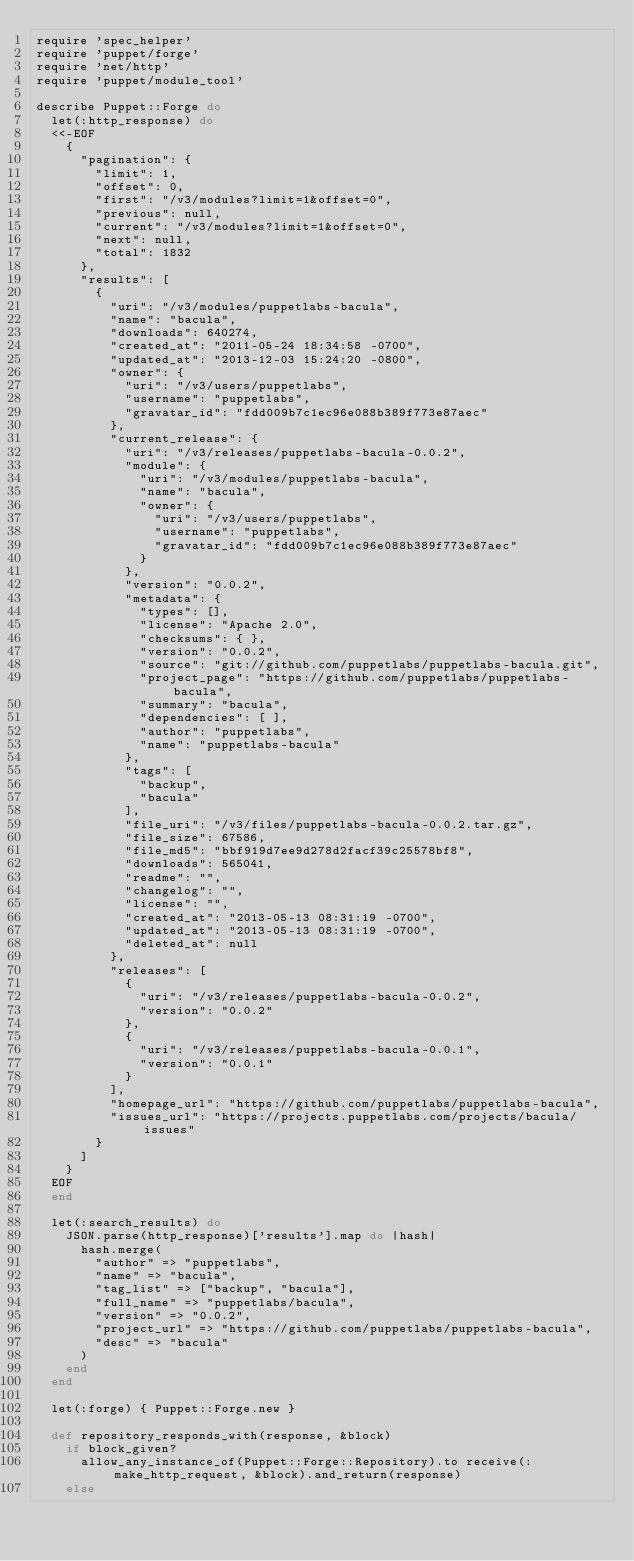Convert code to text. <code><loc_0><loc_0><loc_500><loc_500><_Ruby_>require 'spec_helper'
require 'puppet/forge'
require 'net/http'
require 'puppet/module_tool'

describe Puppet::Forge do
  let(:http_response) do
  <<-EOF
    {
      "pagination": {
        "limit": 1,
        "offset": 0,
        "first": "/v3/modules?limit=1&offset=0",
        "previous": null,
        "current": "/v3/modules?limit=1&offset=0",
        "next": null,
        "total": 1832
      },
      "results": [
        {
          "uri": "/v3/modules/puppetlabs-bacula",
          "name": "bacula",
          "downloads": 640274,
          "created_at": "2011-05-24 18:34:58 -0700",
          "updated_at": "2013-12-03 15:24:20 -0800",
          "owner": {
            "uri": "/v3/users/puppetlabs",
            "username": "puppetlabs",
            "gravatar_id": "fdd009b7c1ec96e088b389f773e87aec"
          },
          "current_release": {
            "uri": "/v3/releases/puppetlabs-bacula-0.0.2",
            "module": {
              "uri": "/v3/modules/puppetlabs-bacula",
              "name": "bacula",
              "owner": {
                "uri": "/v3/users/puppetlabs",
                "username": "puppetlabs",
                "gravatar_id": "fdd009b7c1ec96e088b389f773e87aec"
              }
            },
            "version": "0.0.2",
            "metadata": {
              "types": [],
              "license": "Apache 2.0",
              "checksums": { },
              "version": "0.0.2",
              "source": "git://github.com/puppetlabs/puppetlabs-bacula.git",
              "project_page": "https://github.com/puppetlabs/puppetlabs-bacula",
              "summary": "bacula",
              "dependencies": [ ],
              "author": "puppetlabs",
              "name": "puppetlabs-bacula"
            },
            "tags": [
              "backup",
              "bacula"
            ],
            "file_uri": "/v3/files/puppetlabs-bacula-0.0.2.tar.gz",
            "file_size": 67586,
            "file_md5": "bbf919d7ee9d278d2facf39c25578bf8",
            "downloads": 565041,
            "readme": "",
            "changelog": "",
            "license": "",
            "created_at": "2013-05-13 08:31:19 -0700",
            "updated_at": "2013-05-13 08:31:19 -0700",
            "deleted_at": null
          },
          "releases": [
            {
              "uri": "/v3/releases/puppetlabs-bacula-0.0.2",
              "version": "0.0.2"
            },
            {
              "uri": "/v3/releases/puppetlabs-bacula-0.0.1",
              "version": "0.0.1"
            }
          ],
          "homepage_url": "https://github.com/puppetlabs/puppetlabs-bacula",
          "issues_url": "https://projects.puppetlabs.com/projects/bacula/issues"
        }
      ]
    }
  EOF
  end

  let(:search_results) do
    JSON.parse(http_response)['results'].map do |hash|
      hash.merge(
        "author" => "puppetlabs",
        "name" => "bacula",
        "tag_list" => ["backup", "bacula"],
        "full_name" => "puppetlabs/bacula",
        "version" => "0.0.2",
        "project_url" => "https://github.com/puppetlabs/puppetlabs-bacula",
        "desc" => "bacula"
      )
    end
  end

  let(:forge) { Puppet::Forge.new }

  def repository_responds_with(response, &block)
    if block_given?
      allow_any_instance_of(Puppet::Forge::Repository).to receive(:make_http_request, &block).and_return(response)
    else</code> 